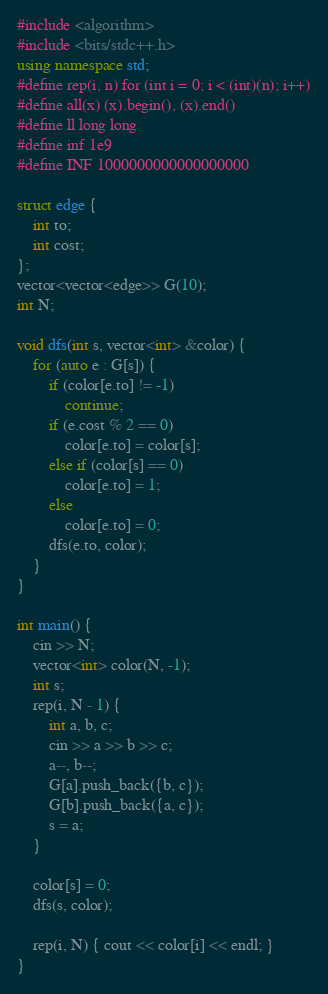<code> <loc_0><loc_0><loc_500><loc_500><_C++_>#include <algorithm>
#include <bits/stdc++.h>
using namespace std;
#define rep(i, n) for (int i = 0; i < (int)(n); i++)
#define all(x) (x).begin(), (x).end()
#define ll long long
#define inf 1e9
#define INF 1000000000000000000

struct edge {
    int to;
    int cost;
};
vector<vector<edge>> G(10);
int N;

void dfs(int s, vector<int> &color) {
    for (auto e : G[s]) {
        if (color[e.to] != -1)
            continue;
        if (e.cost % 2 == 0)
            color[e.to] = color[s];
        else if (color[s] == 0)
            color[e.to] = 1;
        else
            color[e.to] = 0;
        dfs(e.to, color);
    }
}

int main() {
    cin >> N;
    vector<int> color(N, -1);
    int s;
    rep(i, N - 1) {
        int a, b, c;
        cin >> a >> b >> c;
        a--, b--;
        G[a].push_back({b, c});
        G[b].push_back({a, c});
        s = a;
    }

    color[s] = 0;
    dfs(s, color);

    rep(i, N) { cout << color[i] << endl; }
}</code> 